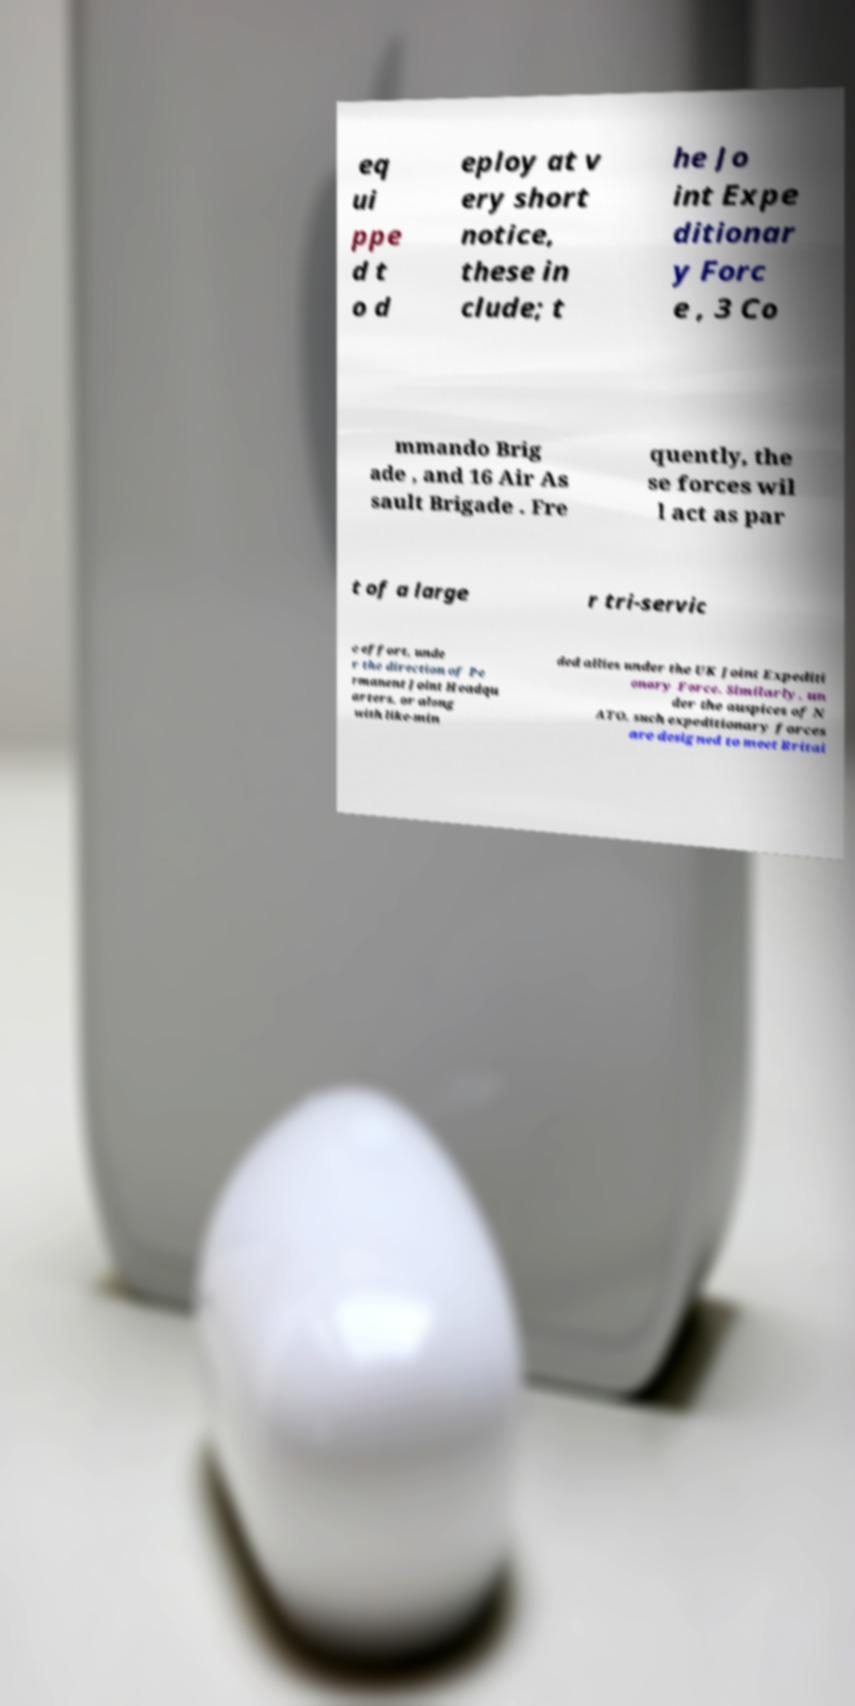Please identify and transcribe the text found in this image. eq ui ppe d t o d eploy at v ery short notice, these in clude; t he Jo int Expe ditionar y Forc e , 3 Co mmando Brig ade , and 16 Air As sault Brigade . Fre quently, the se forces wil l act as par t of a large r tri-servic e effort, unde r the direction of Pe rmanent Joint Headqu arters, or along with like-min ded allies under the UK Joint Expediti onary Force. Similarly, un der the auspices of N ATO, such expeditionary forces are designed to meet Britai 